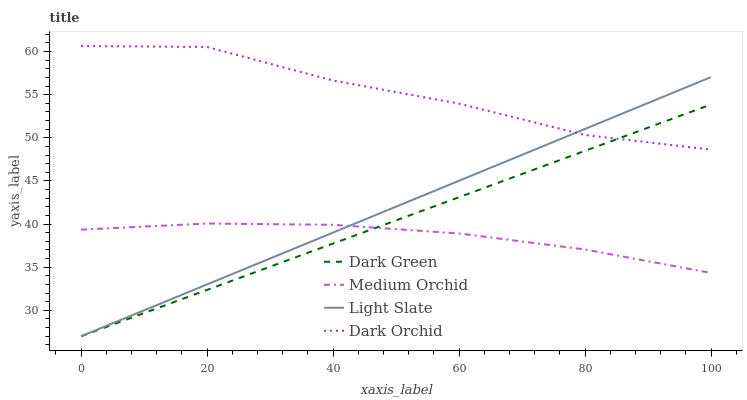Does Medium Orchid have the minimum area under the curve?
Answer yes or no. Yes. Does Dark Orchid have the maximum area under the curve?
Answer yes or no. Yes. Does Dark Orchid have the minimum area under the curve?
Answer yes or no. No. Does Medium Orchid have the maximum area under the curve?
Answer yes or no. No. Is Light Slate the smoothest?
Answer yes or no. Yes. Is Dark Orchid the roughest?
Answer yes or no. Yes. Is Medium Orchid the smoothest?
Answer yes or no. No. Is Medium Orchid the roughest?
Answer yes or no. No. Does Light Slate have the lowest value?
Answer yes or no. Yes. Does Medium Orchid have the lowest value?
Answer yes or no. No. Does Dark Orchid have the highest value?
Answer yes or no. Yes. Does Medium Orchid have the highest value?
Answer yes or no. No. Is Medium Orchid less than Dark Orchid?
Answer yes or no. Yes. Is Dark Orchid greater than Medium Orchid?
Answer yes or no. Yes. Does Light Slate intersect Dark Orchid?
Answer yes or no. Yes. Is Light Slate less than Dark Orchid?
Answer yes or no. No. Is Light Slate greater than Dark Orchid?
Answer yes or no. No. Does Medium Orchid intersect Dark Orchid?
Answer yes or no. No. 